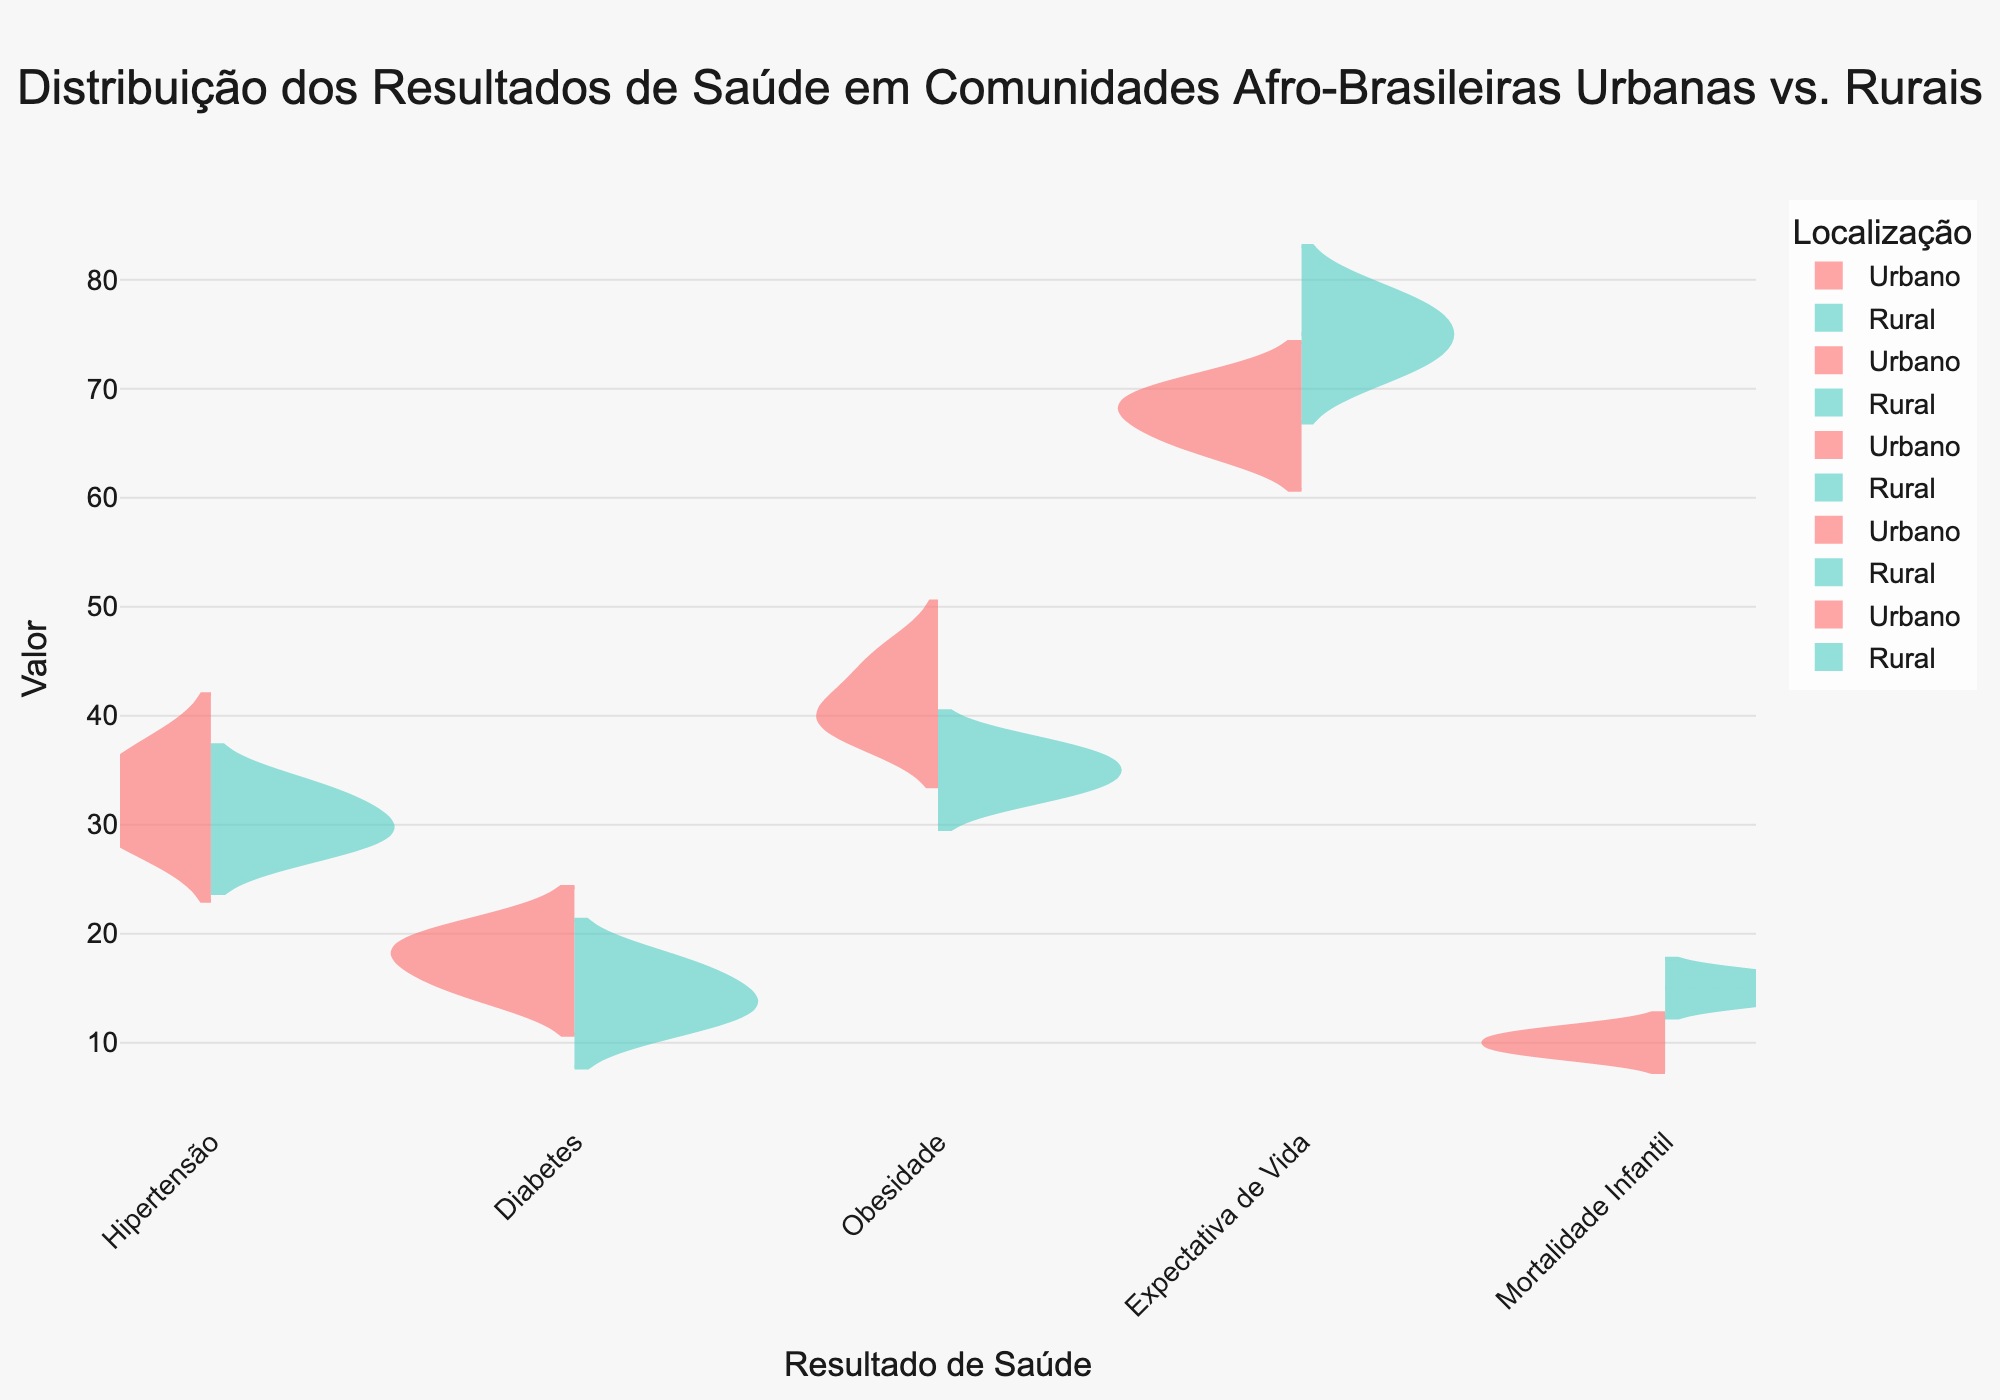Which health outcome has the widest spread of values in urban areas? By looking at the spread of the violin plots on the left side (Urbano) for each health outcome, the one with the widest spread touches both the lowest and highest values.
Answer: Hypertension What is the median value for life expectancy in rural communities? The median line for life expectancy in rural areas (Rural) is visible in the center of the violin section on the right side. The median value can be read directly from this line.
Answer: 75 How does the mean value of infant mortality in urban areas compare to rural areas? The mean lines for infant mortality can be identified in both the Urbano and Rural sections of the violin plots. Comparing their positions will reveal which one is higher. The Urbano mean is around 10, while the Rural mean is around 15.
Answer: The mean in rural areas is higher Which health outcomes show a higher variability in values for rural communities compared to urban communities? By comparing the widths and spreads of violin plots for Rural versus Urbano sections, the health outcomes with wider plots in Rural areas can be identified. Inferring higher variability from wider spreads: Infant Mortality, Hypertension, and Obesity show higher variability.
Answer: Infant Mortality, Hypertension, Obesity What is the range of values for diabetes in urban communities? The range can be seen by looking at the lowest and highest points in the Urbano section of the violin plot for diabetes. The range extends from 15 to 20.
Answer: 15 to 20 